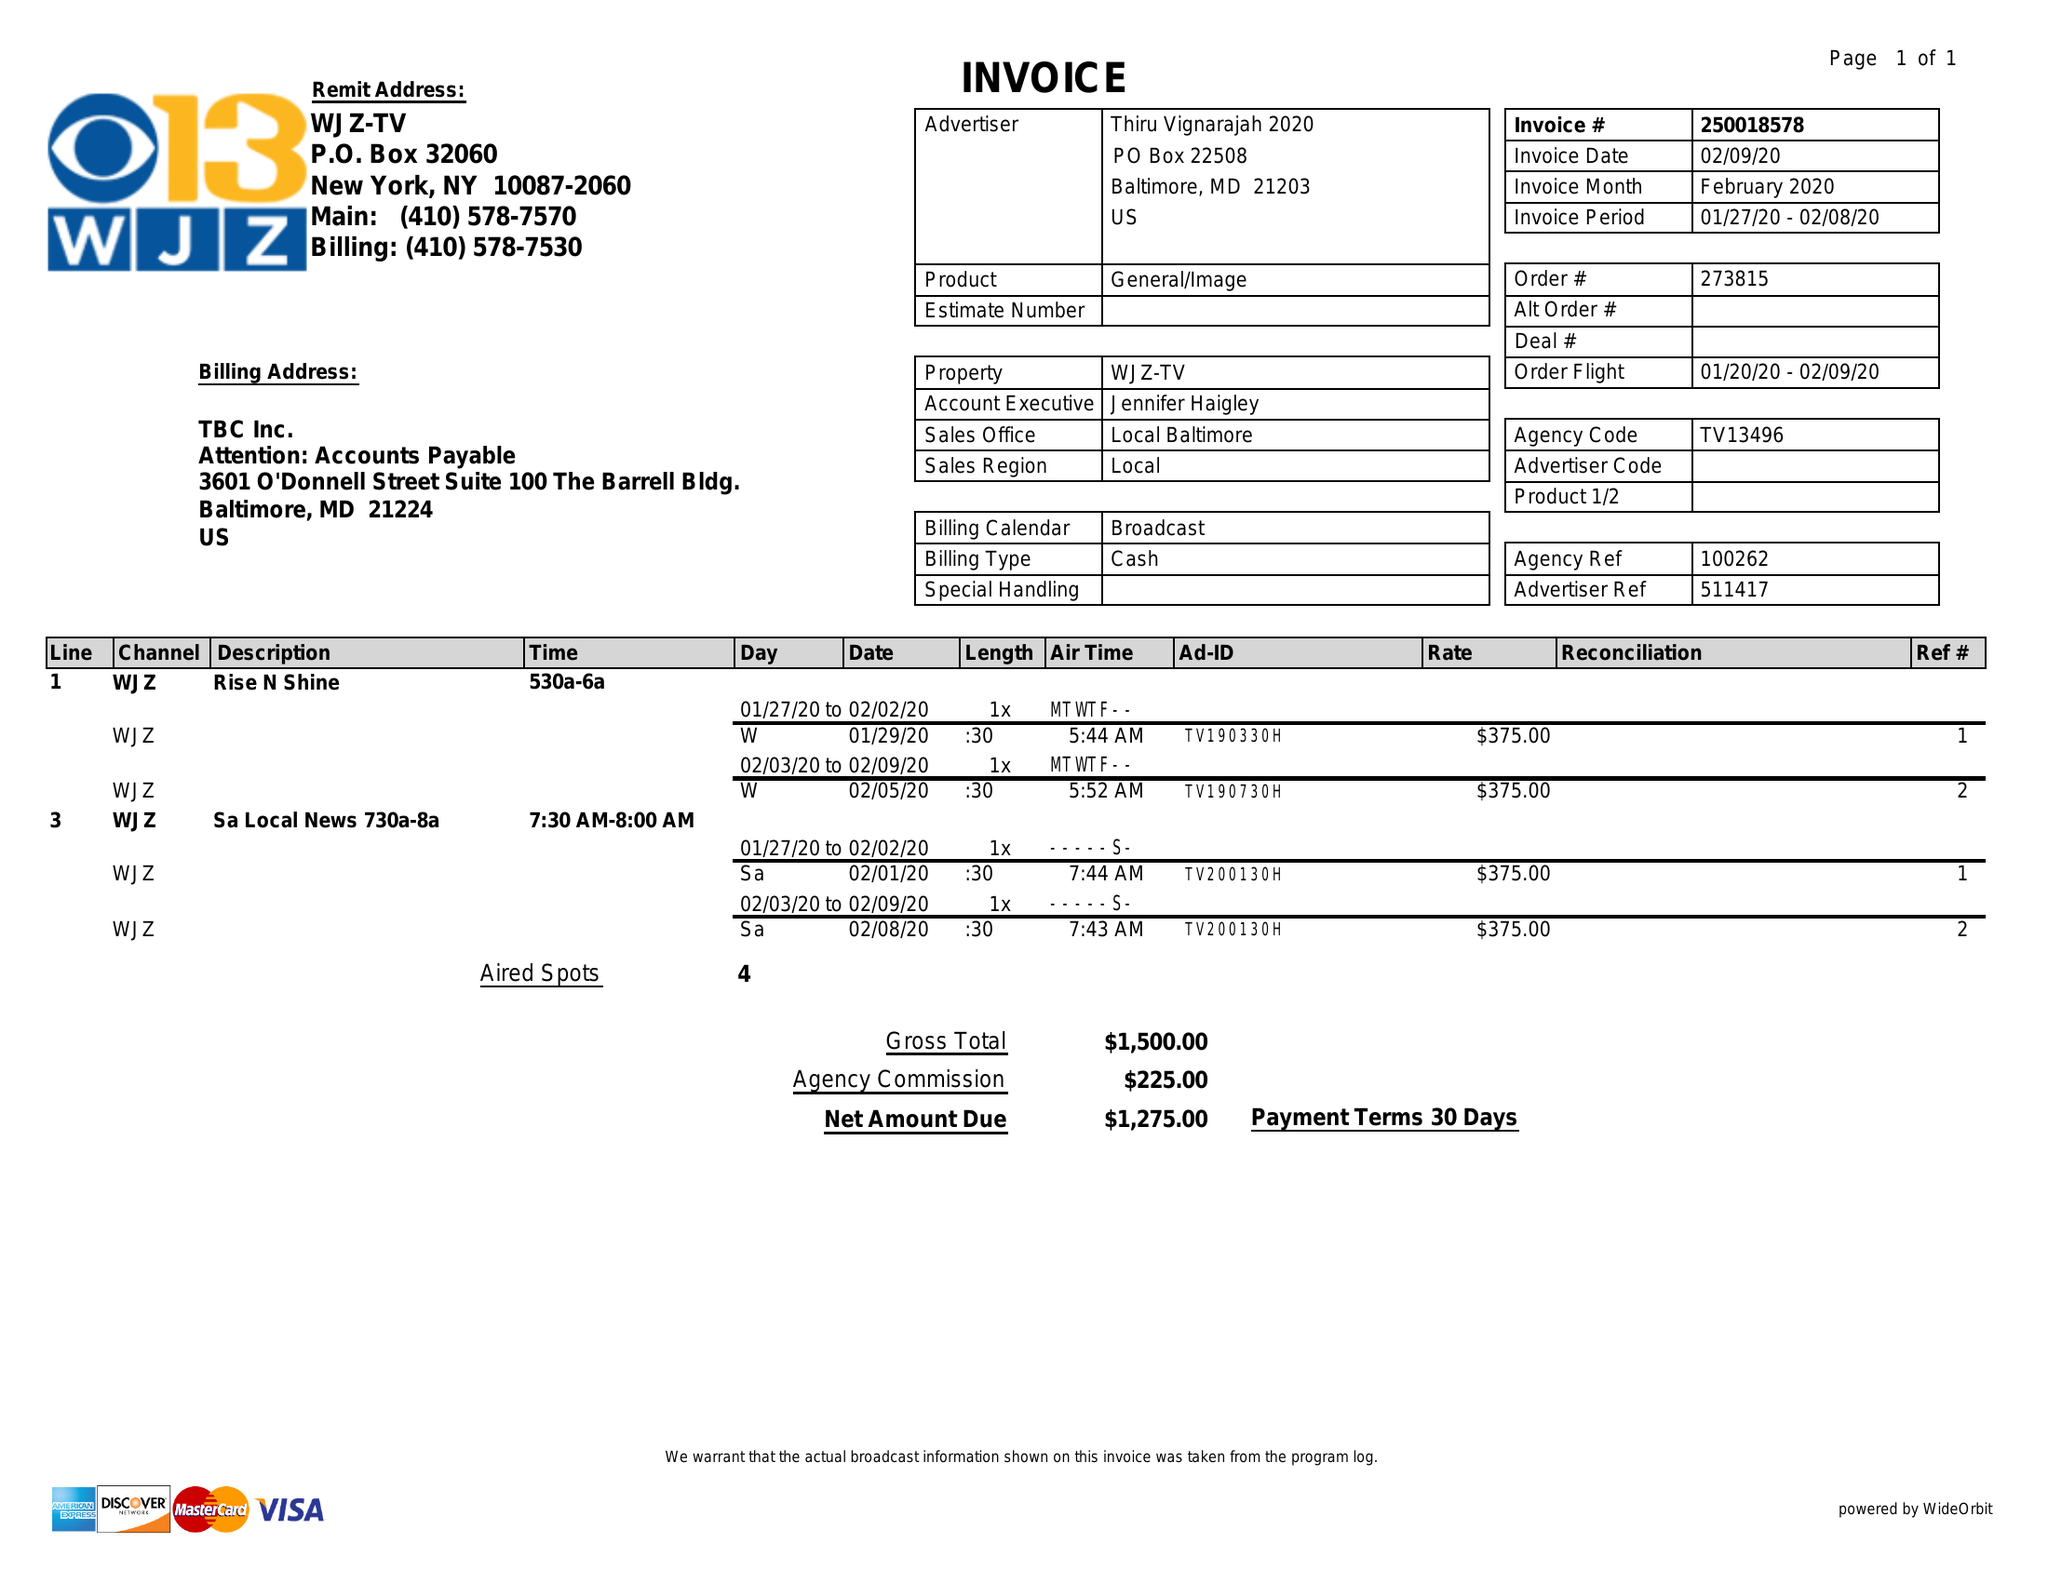What is the value for the gross_amount?
Answer the question using a single word or phrase. 1500.00 